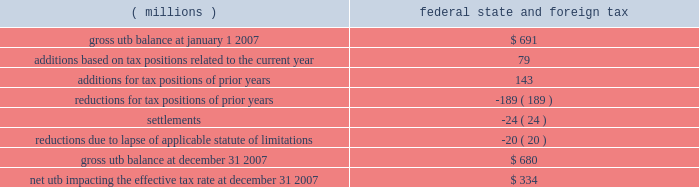The company files income tax returns in the u.s .
Federal jurisdiction , and various states and foreign jurisdictions .
With few exceptions , the company is no longer subject to u.s .
Federal , state and local , or non-u.s .
Income tax examinations by tax authorities for years before 1999 .
It is anticipated that its examination for the company 2019s u.s .
Income tax returns for the years 2002 through 2004 will be completed by the end of first quarter 2008 .
As of december 31 , 2007 , the irs has proposed adjustments to the company 2019s tax positions for which the company is fully reserved .
Payments relating to any proposed assessments arising from the 2002 through 2004 audit may not be made until a final agreement is reached between the company and the irs on such assessments or upon a final resolution resulting from the administrative appeals process or judicial action .
In addition to the u.s .
Federal examination , there is also limited audit activity in several u.s .
State and foreign jurisdictions .
Currently , the company expects the liability for unrecognized tax benefits to change by an insignificant amount during the next 12 months .
The company adopted the provisions of fasb interpretation no .
48 , 201caccounting for uncertainty in income taxes , 201d on january 1 , 2007 .
As a result of the implementation of interpretation 48 , the company recognized an immaterial increase in the liability for unrecognized tax benefits , which was accounted for as a reduction to the january 1 , 2007 , balance of retained earnings .
A reconciliation of the beginning and ending amount of gross unrecognized tax benefits ( 201cutb 201d ) is as follows : ( millions ) federal , state , and foreign tax .
The total amount of unrecognized tax benefits that , if recognized , would affect the effective tax rate as of january 1 , 2007 and december 31 , 2007 , respectively , are $ 261 million and $ 334 million .
The ending net utb results from adjusting the gross balance at december 31 , 2007 for items such as federal , state , and non-u.s .
Deferred items , interest and penalties , and deductible taxes .
The net utb is included as components of accrued income taxes and other liabilities within the consolidated balance sheet .
The company recognizes interest and penalties accrued related to unrecognized tax benefits in tax expense .
At january 1 , 2007 and december 31 , 2007 , accrued interest and penalties on a gross basis were $ 65 million and $ 69 million , respectively .
Included in these interest and penalty amounts is interest and penalties related to tax positions for which the ultimate deductibility is highly certain but for which there is uncertainty about the timing of such deductibility .
Because of the impact of deferred tax accounting , other than interest and penalties , the disallowance of the shorter deductibility period would not affect the annual effective tax rate but would accelerate the payment of cash to the taxing authority to an earlier period .
In 2007 , the company completed the preparation and filing of its 2006 u.s .
Federal and state income tax returns , which did not result in any material changes to the company 2019s financial position .
In 2006 , an audit of the company 2019s u.s .
Tax returns for years through 2001 was completed .
The company and the internal revenue service reached a final settlement for these years , including an agreement on the amount of a refund claim to be filed by the company .
The company also substantially resolved audits in certain european countries .
In addition , the company completed the preparation and filing of its 2005 u.s .
Federal income tax return and the corresponding 2005 state income tax returns .
The adjustments from amounts previously estimated in the u.s .
Federal and state income tax returns ( both positive and negative ) included lower u.s .
Taxes on dividends received from the company's foreign subsidiaries .
The company also made quarterly adjustments ( both positive and negative ) to its reserves for tax contingencies .
Considering the developments noted above and other factors , including the impact on open audit years of the recent resolution of issues in various audits , these reassessments resulted in a reduction of the reserves in 2006 by $ 149 million , inclusive of the expected amount of certain refund claims .
In 2005 , the company announced its intent to reinvest $ 1.7 billion of foreign earnings in the united states pursuant to the provisions of the american jobs creation act of 2004 .
This act provided the company the opportunity to tax- .
At january 12007 what was the percent of the interest and penalties included in the gross unrecognized tax benefits? 
Rationale: at january 12007 the percent of the interest and penalties included in the gross unrecognized tax benefits was 19.4%
Computations: ((65 + 69) / 691)
Answer: 0.19392. 